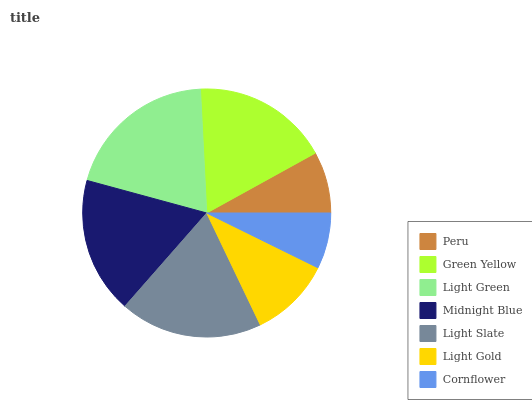Is Cornflower the minimum?
Answer yes or no. Yes. Is Light Green the maximum?
Answer yes or no. Yes. Is Green Yellow the minimum?
Answer yes or no. No. Is Green Yellow the maximum?
Answer yes or no. No. Is Green Yellow greater than Peru?
Answer yes or no. Yes. Is Peru less than Green Yellow?
Answer yes or no. Yes. Is Peru greater than Green Yellow?
Answer yes or no. No. Is Green Yellow less than Peru?
Answer yes or no. No. Is Midnight Blue the high median?
Answer yes or no. Yes. Is Midnight Blue the low median?
Answer yes or no. Yes. Is Light Slate the high median?
Answer yes or no. No. Is Cornflower the low median?
Answer yes or no. No. 